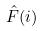Convert formula to latex. <formula><loc_0><loc_0><loc_500><loc_500>\hat { F } ( i )</formula> 